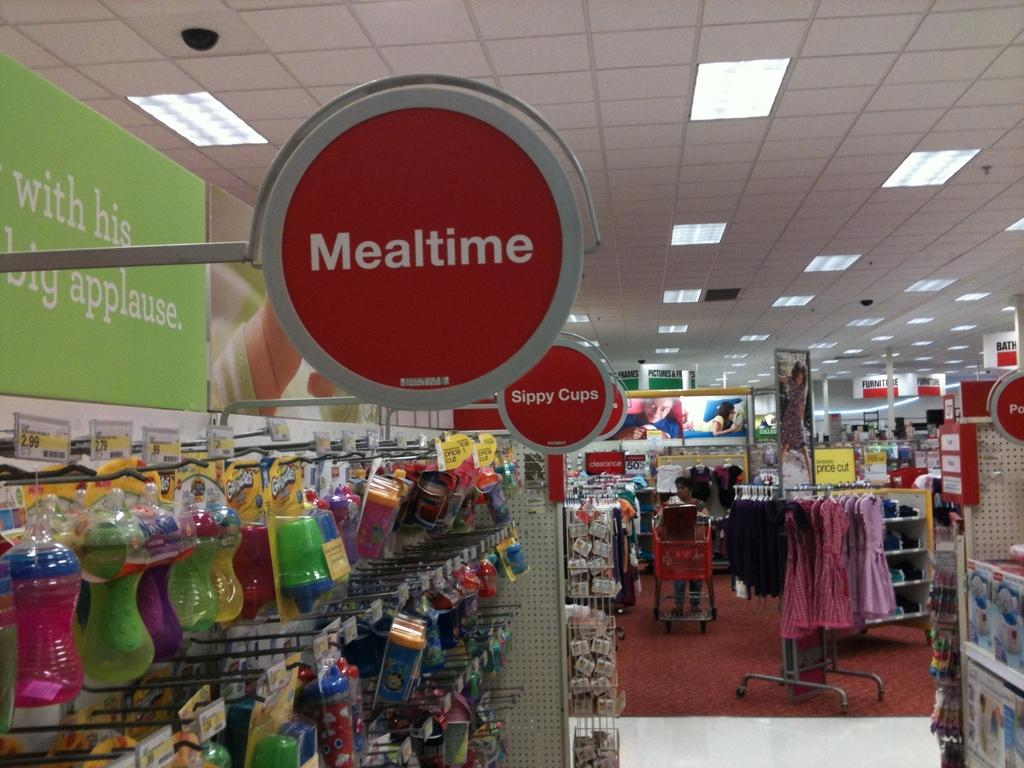<image>
Present a compact description of the photo's key features. A sign in a store displaying the word MEALTIME 